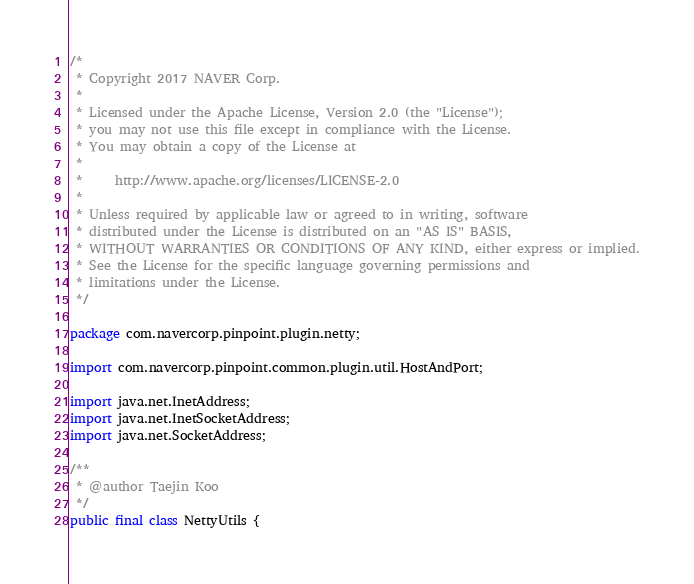<code> <loc_0><loc_0><loc_500><loc_500><_Java_>/*
 * Copyright 2017 NAVER Corp.
 *
 * Licensed under the Apache License, Version 2.0 (the "License");
 * you may not use this file except in compliance with the License.
 * You may obtain a copy of the License at
 *
 *     http://www.apache.org/licenses/LICENSE-2.0
 *
 * Unless required by applicable law or agreed to in writing, software
 * distributed under the License is distributed on an "AS IS" BASIS,
 * WITHOUT WARRANTIES OR CONDITIONS OF ANY KIND, either express or implied.
 * See the License for the specific language governing permissions and
 * limitations under the License.
 */

package com.navercorp.pinpoint.plugin.netty;

import com.navercorp.pinpoint.common.plugin.util.HostAndPort;

import java.net.InetAddress;
import java.net.InetSocketAddress;
import java.net.SocketAddress;

/**
 * @author Taejin Koo
 */
public final class NettyUtils {
</code> 